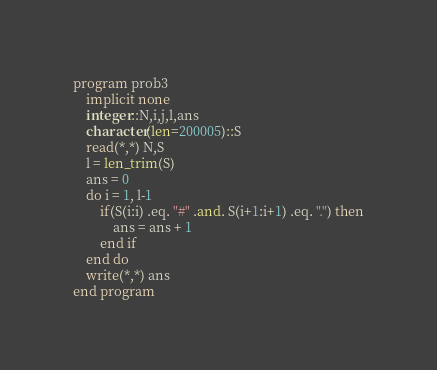Convert code to text. <code><loc_0><loc_0><loc_500><loc_500><_FORTRAN_>program prob3
    implicit none
    integer::N,i,j,l,ans
    character(len=200005)::S
    read(*,*) N,S
    l = len_trim(S)
    ans = 0
    do i = 1, l-1
        if(S(i:i) .eq. "#" .and. S(i+1:i+1) .eq. ".") then
            ans = ans + 1
        end if
    end do
    write(*,*) ans
end program</code> 